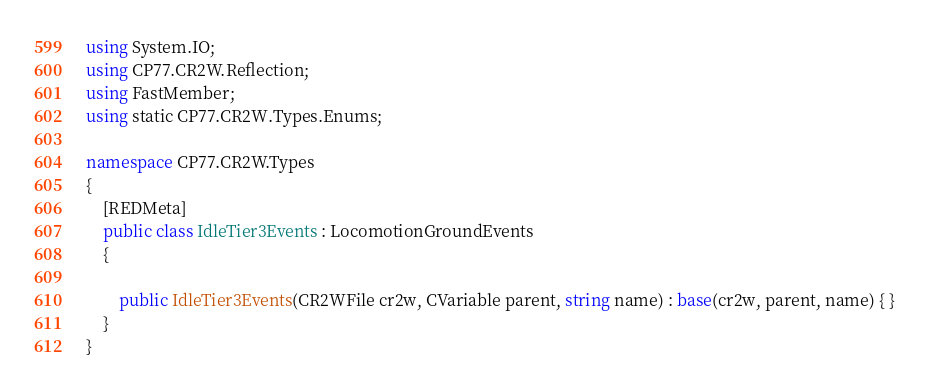<code> <loc_0><loc_0><loc_500><loc_500><_C#_>using System.IO;
using CP77.CR2W.Reflection;
using FastMember;
using static CP77.CR2W.Types.Enums;

namespace CP77.CR2W.Types
{
	[REDMeta]
	public class IdleTier3Events : LocomotionGroundEvents
	{

		public IdleTier3Events(CR2WFile cr2w, CVariable parent, string name) : base(cr2w, parent, name) { }
	}
}
</code> 